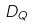<formula> <loc_0><loc_0><loc_500><loc_500>D _ { Q }</formula> 